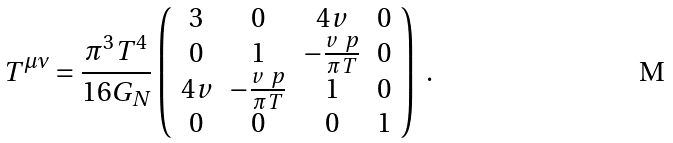Convert formula to latex. <formula><loc_0><loc_0><loc_500><loc_500>T ^ { \mu \nu } = \frac { \pi ^ { 3 } T ^ { 4 } } { 1 6 G _ { N } } \left ( \begin{array} { c c c c } 3 & 0 & 4 v & 0 \\ 0 & 1 & - \frac { v \ p } { \pi T } & 0 \\ 4 v & - \frac { v \ p } { \pi T } & 1 & 0 \\ 0 & 0 & 0 & 1 \end{array} \right ) \ .</formula> 